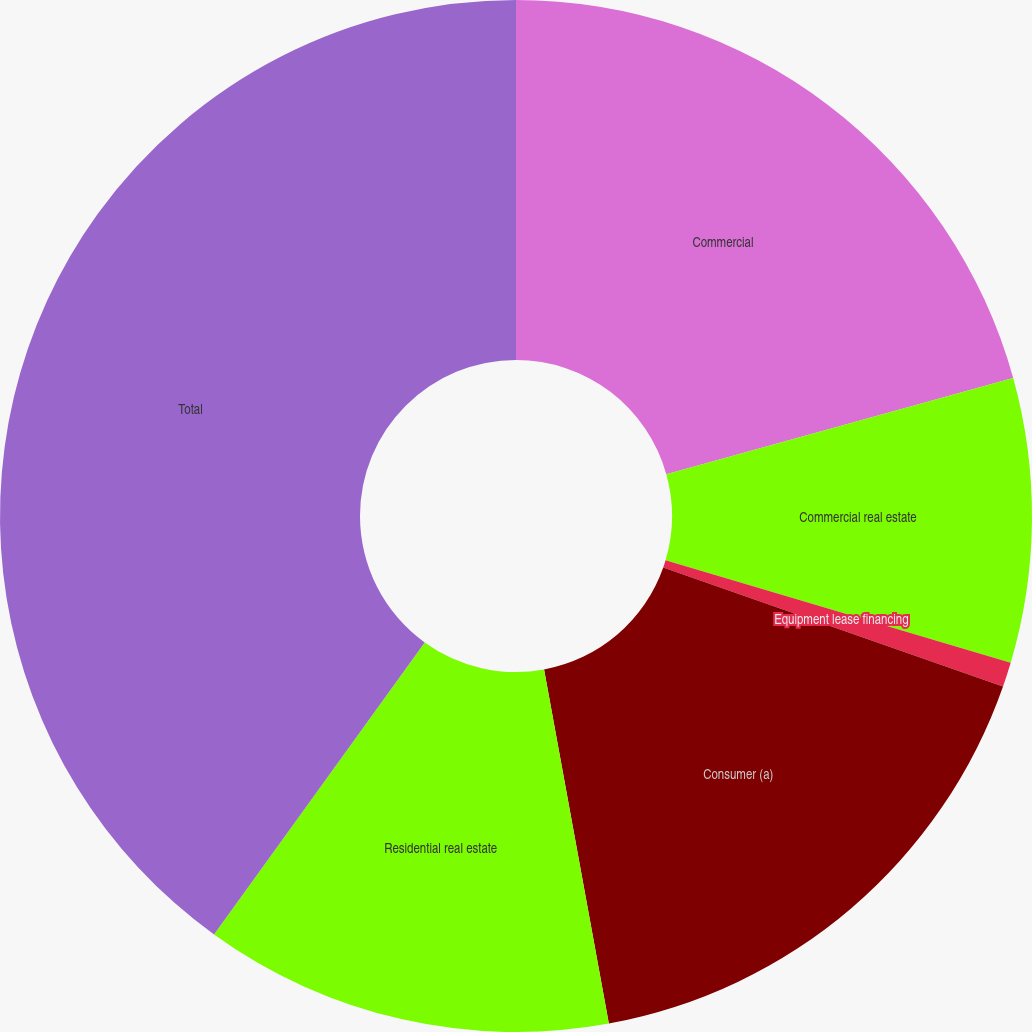Convert chart. <chart><loc_0><loc_0><loc_500><loc_500><pie_chart><fcel>Commercial<fcel>Commercial real estate<fcel>Equipment lease financing<fcel>Consumer (a)<fcel>Residential real estate<fcel>Total<nl><fcel>20.69%<fcel>8.9%<fcel>0.77%<fcel>16.76%<fcel>12.83%<fcel>40.05%<nl></chart> 